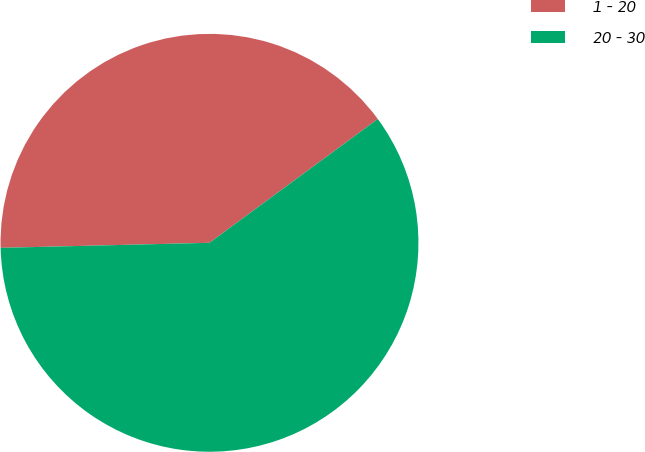Convert chart to OTSL. <chart><loc_0><loc_0><loc_500><loc_500><pie_chart><fcel>1 - 20<fcel>20 - 30<nl><fcel>40.29%<fcel>59.71%<nl></chart> 